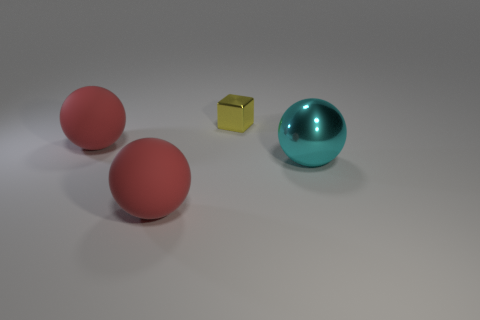How many small yellow blocks are left of the big ball that is behind the big thing that is right of the yellow block?
Your response must be concise. 0. There is a tiny yellow shiny cube; how many red matte balls are on the right side of it?
Provide a short and direct response. 0. What color is the rubber object that is behind the large cyan ball that is in front of the block?
Give a very brief answer. Red. What number of other things are there of the same material as the small block
Give a very brief answer. 1. Are there an equal number of tiny yellow shiny objects that are in front of the cyan thing and cyan things?
Your answer should be very brief. No. What material is the small block behind the big red ball to the left of the object in front of the metallic sphere?
Your answer should be very brief. Metal. There is a rubber object in front of the big metal sphere; what color is it?
Offer a very short reply. Red. Is there any other thing that is the same shape as the yellow metallic object?
Provide a short and direct response. No. What size is the matte thing on the left side of the large thing that is in front of the large cyan metallic sphere?
Your answer should be very brief. Large. Are there an equal number of shiny blocks that are behind the metal cube and metal spheres in front of the cyan metal thing?
Offer a terse response. Yes. 